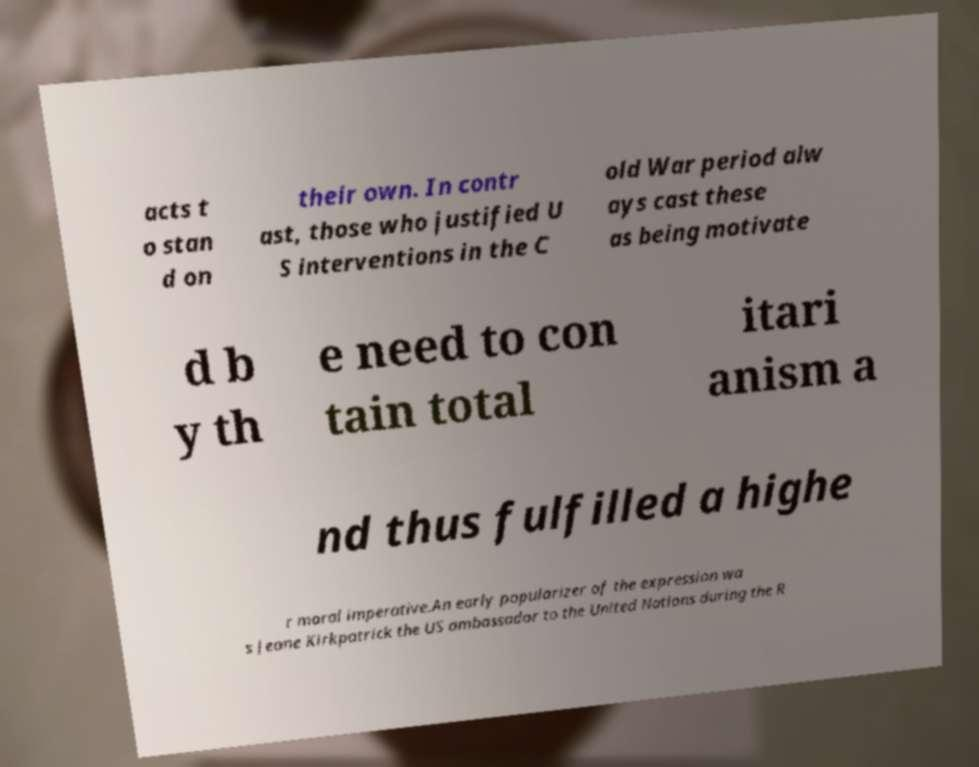Please identify and transcribe the text found in this image. acts t o stan d on their own. In contr ast, those who justified U S interventions in the C old War period alw ays cast these as being motivate d b y th e need to con tain total itari anism a nd thus fulfilled a highe r moral imperative.An early popularizer of the expression wa s Jeane Kirkpatrick the US ambassador to the United Nations during the R 